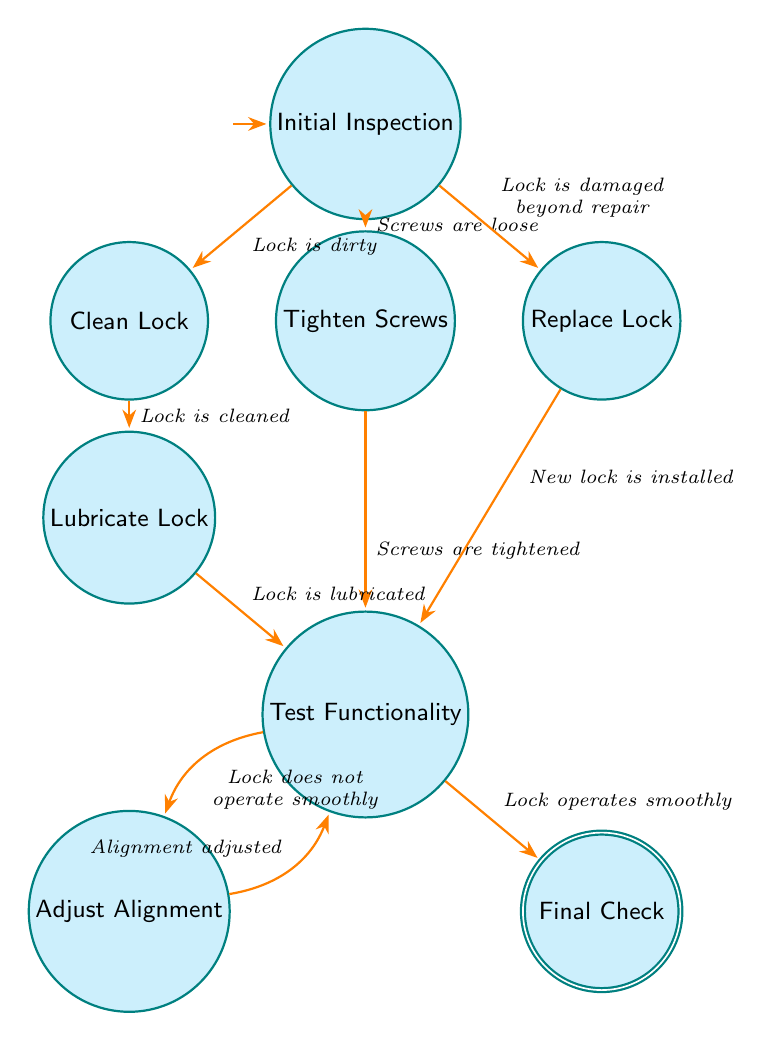What is the first step in the maintenance process? The first state in the diagram is "Initial Inspection," which indicates that the process starts with inspecting the sliding door lock for visible damage or misalignment.
Answer: Initial Inspection How many states are present in the diagram? By counting the states listed in the data section, there are a total of eight states in the diagram related to the maintenance and troubleshooting of sliding door locks.
Answer: Eight What step follows cleaning the lock? After the "Clean Lock" state, the flow transitions to the "Lubricate Lock" state upon the condition that the lock is cleaned.
Answer: Lubricate Lock What condition leads from tightening screws to testing functionality? The transition from "Tighten Screws" to "Test Functionality" occurs when the condition "Screws are tightened" is satisfied after the screws have been addressed.
Answer: Screws are tightened What action is taken if the lock is damaged beyond repair? If the lock is determined to be damaged beyond repair, the transition will lead to the "Replace Lock" state, where a new lock would be installed.
Answer: Replace Lock How does the process proceed if the lock does not operate smoothly after testing? If the lock does not operate smoothly during the "Test Functionality" stage, the process will transition to the "Adjust Alignment" state to correct any misalignments before re-testing the functionality.
Answer: Adjust Alignment What final step is taken after confirming the lock operates smoothly? Once it is confirmed that the lock operates smoothly, the next step in the process is to perform a "Final Check" to ensure everything is functioning correctly and securely.
Answer: Final Check What happens after adjusting alignment? Following the "Adjust Alignment" state, the process returns to the "Test Functionality" node to verify whether the adjustments made have improved the lock's operation.
Answer: Test Functionality 